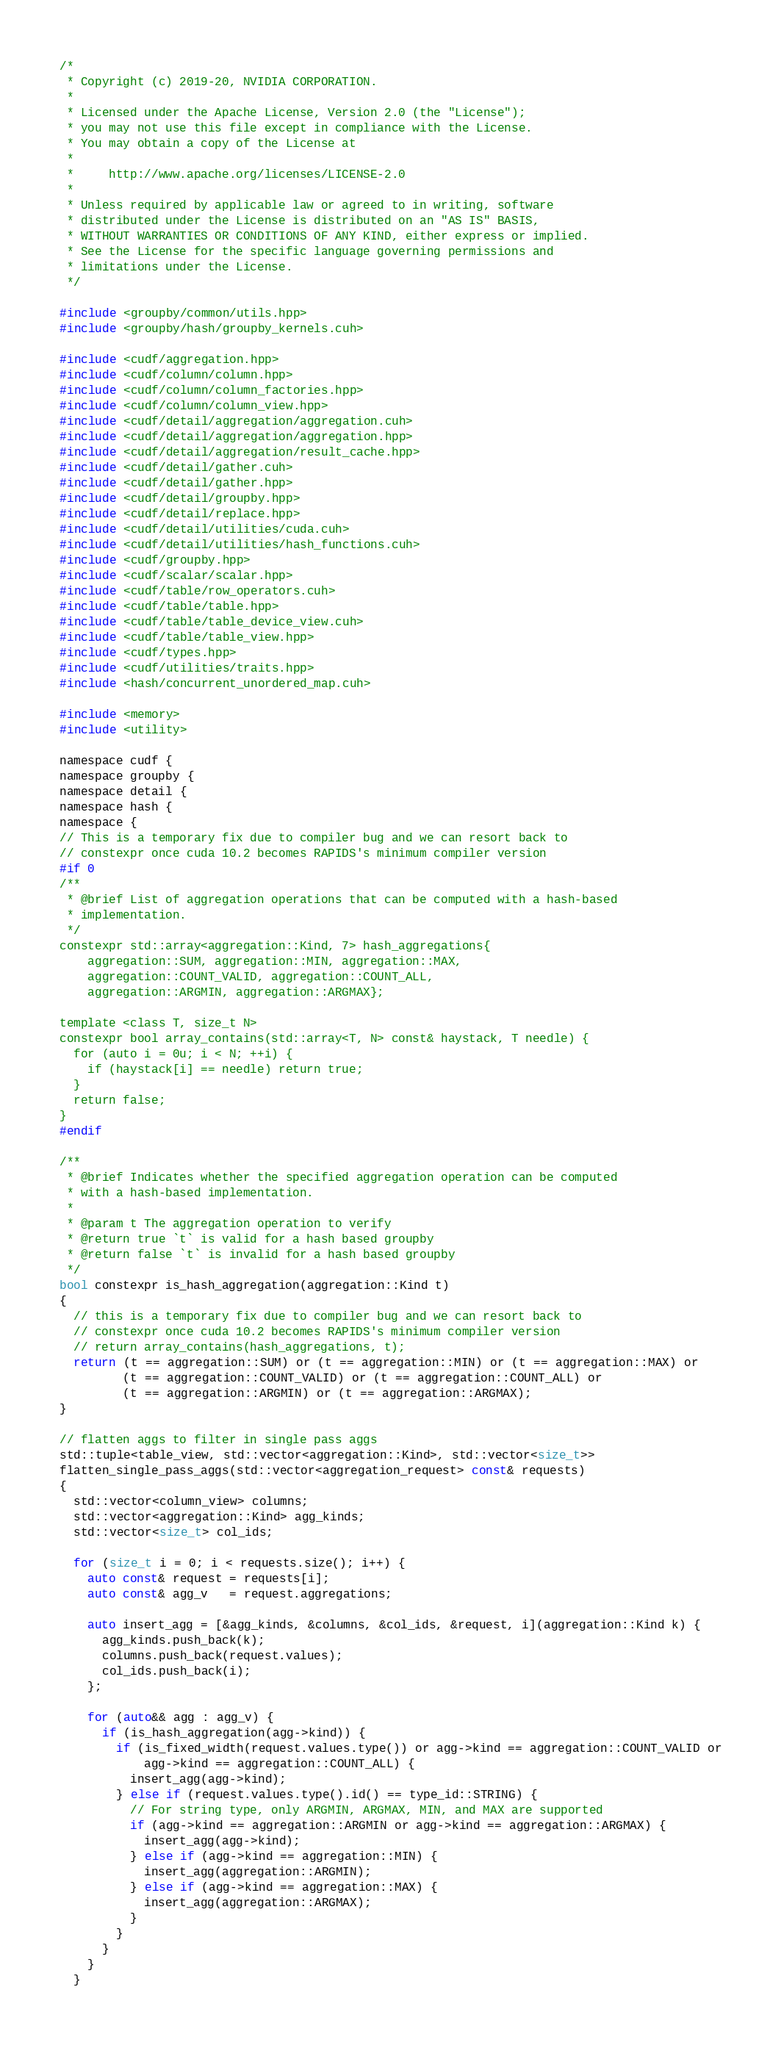<code> <loc_0><loc_0><loc_500><loc_500><_Cuda_>/*
 * Copyright (c) 2019-20, NVIDIA CORPORATION.
 *
 * Licensed under the Apache License, Version 2.0 (the "License");
 * you may not use this file except in compliance with the License.
 * You may obtain a copy of the License at
 *
 *     http://www.apache.org/licenses/LICENSE-2.0
 *
 * Unless required by applicable law or agreed to in writing, software
 * distributed under the License is distributed on an "AS IS" BASIS,
 * WITHOUT WARRANTIES OR CONDITIONS OF ANY KIND, either express or implied.
 * See the License for the specific language governing permissions and
 * limitations under the License.
 */

#include <groupby/common/utils.hpp>
#include <groupby/hash/groupby_kernels.cuh>

#include <cudf/aggregation.hpp>
#include <cudf/column/column.hpp>
#include <cudf/column/column_factories.hpp>
#include <cudf/column/column_view.hpp>
#include <cudf/detail/aggregation/aggregation.cuh>
#include <cudf/detail/aggregation/aggregation.hpp>
#include <cudf/detail/aggregation/result_cache.hpp>
#include <cudf/detail/gather.cuh>
#include <cudf/detail/gather.hpp>
#include <cudf/detail/groupby.hpp>
#include <cudf/detail/replace.hpp>
#include <cudf/detail/utilities/cuda.cuh>
#include <cudf/detail/utilities/hash_functions.cuh>
#include <cudf/groupby.hpp>
#include <cudf/scalar/scalar.hpp>
#include <cudf/table/row_operators.cuh>
#include <cudf/table/table.hpp>
#include <cudf/table/table_device_view.cuh>
#include <cudf/table/table_view.hpp>
#include <cudf/types.hpp>
#include <cudf/utilities/traits.hpp>
#include <hash/concurrent_unordered_map.cuh>

#include <memory>
#include <utility>

namespace cudf {
namespace groupby {
namespace detail {
namespace hash {
namespace {
// This is a temporary fix due to compiler bug and we can resort back to
// constexpr once cuda 10.2 becomes RAPIDS's minimum compiler version
#if 0
/**
 * @brief List of aggregation operations that can be computed with a hash-based
 * implementation.
 */
constexpr std::array<aggregation::Kind, 7> hash_aggregations{
    aggregation::SUM, aggregation::MIN, aggregation::MAX,
    aggregation::COUNT_VALID, aggregation::COUNT_ALL,
    aggregation::ARGMIN, aggregation::ARGMAX};

template <class T, size_t N>
constexpr bool array_contains(std::array<T, N> const& haystack, T needle) {
  for (auto i = 0u; i < N; ++i) {
    if (haystack[i] == needle) return true;
  }
  return false;
}
#endif

/**
 * @brief Indicates whether the specified aggregation operation can be computed
 * with a hash-based implementation.
 *
 * @param t The aggregation operation to verify
 * @return true `t` is valid for a hash based groupby
 * @return false `t` is invalid for a hash based groupby
 */
bool constexpr is_hash_aggregation(aggregation::Kind t)
{
  // this is a temporary fix due to compiler bug and we can resort back to
  // constexpr once cuda 10.2 becomes RAPIDS's minimum compiler version
  // return array_contains(hash_aggregations, t);
  return (t == aggregation::SUM) or (t == aggregation::MIN) or (t == aggregation::MAX) or
         (t == aggregation::COUNT_VALID) or (t == aggregation::COUNT_ALL) or
         (t == aggregation::ARGMIN) or (t == aggregation::ARGMAX);
}

// flatten aggs to filter in single pass aggs
std::tuple<table_view, std::vector<aggregation::Kind>, std::vector<size_t>>
flatten_single_pass_aggs(std::vector<aggregation_request> const& requests)
{
  std::vector<column_view> columns;
  std::vector<aggregation::Kind> agg_kinds;
  std::vector<size_t> col_ids;

  for (size_t i = 0; i < requests.size(); i++) {
    auto const& request = requests[i];
    auto const& agg_v   = request.aggregations;

    auto insert_agg = [&agg_kinds, &columns, &col_ids, &request, i](aggregation::Kind k) {
      agg_kinds.push_back(k);
      columns.push_back(request.values);
      col_ids.push_back(i);
    };

    for (auto&& agg : agg_v) {
      if (is_hash_aggregation(agg->kind)) {
        if (is_fixed_width(request.values.type()) or agg->kind == aggregation::COUNT_VALID or
            agg->kind == aggregation::COUNT_ALL) {
          insert_agg(agg->kind);
        } else if (request.values.type().id() == type_id::STRING) {
          // For string type, only ARGMIN, ARGMAX, MIN, and MAX are supported
          if (agg->kind == aggregation::ARGMIN or agg->kind == aggregation::ARGMAX) {
            insert_agg(agg->kind);
          } else if (agg->kind == aggregation::MIN) {
            insert_agg(aggregation::ARGMIN);
          } else if (agg->kind == aggregation::MAX) {
            insert_agg(aggregation::ARGMAX);
          }
        }
      }
    }
  }</code> 